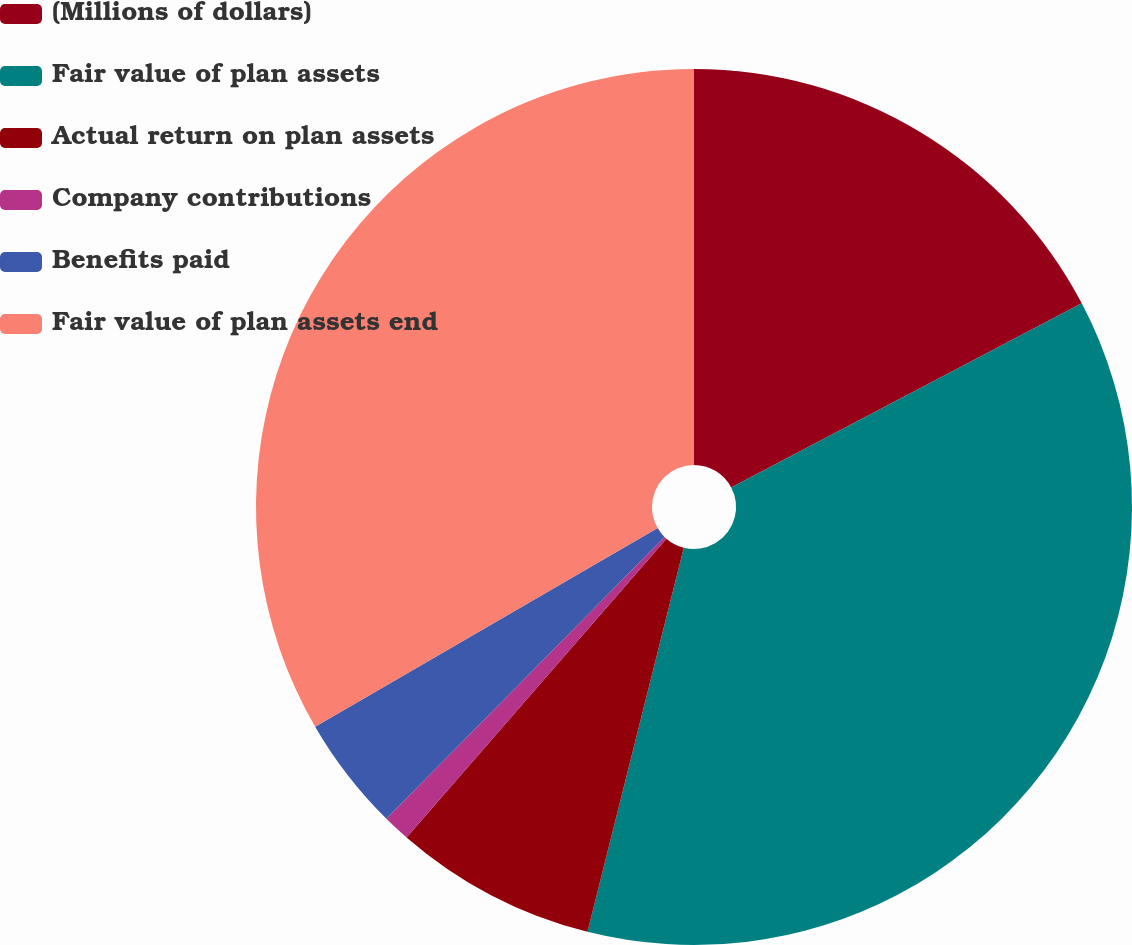<chart> <loc_0><loc_0><loc_500><loc_500><pie_chart><fcel>(Millions of dollars)<fcel>Fair value of plan assets<fcel>Actual return on plan assets<fcel>Company contributions<fcel>Benefits paid<fcel>Fair value of plan assets end<nl><fcel>17.3%<fcel>36.6%<fcel>7.48%<fcel>1.0%<fcel>4.24%<fcel>33.36%<nl></chart> 